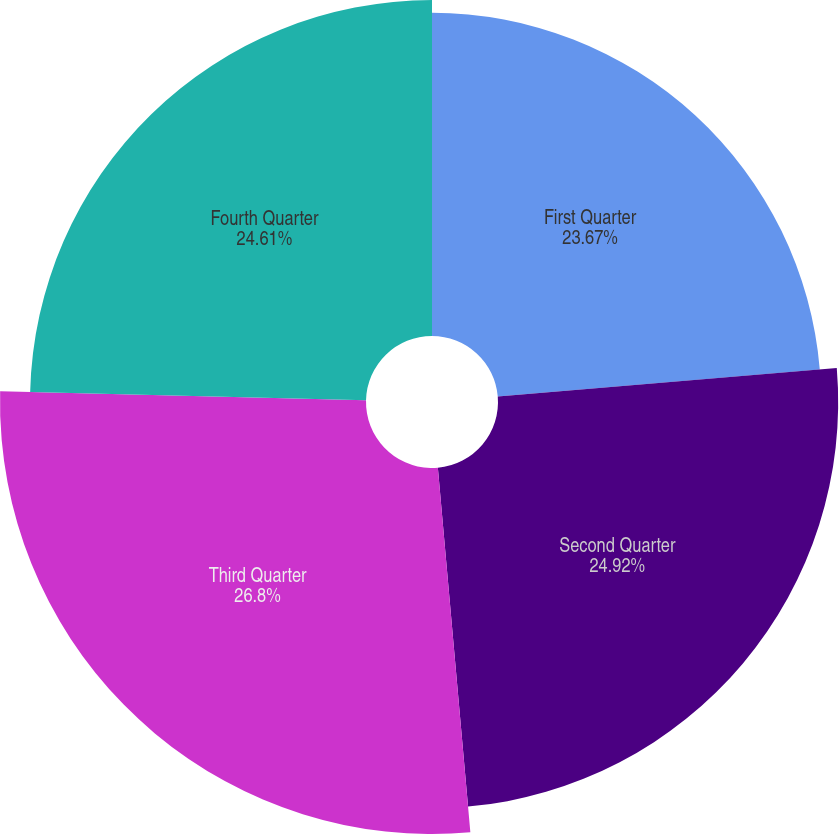Convert chart to OTSL. <chart><loc_0><loc_0><loc_500><loc_500><pie_chart><fcel>First Quarter<fcel>Second Quarter<fcel>Third Quarter<fcel>Fourth Quarter<nl><fcel>23.67%<fcel>24.92%<fcel>26.81%<fcel>24.61%<nl></chart> 